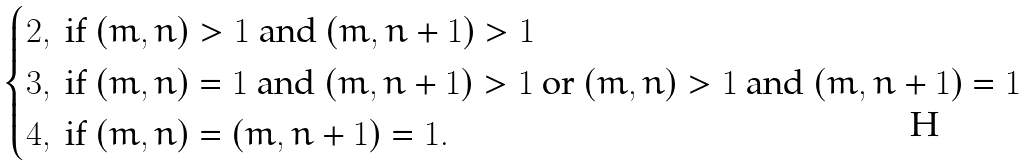Convert formula to latex. <formula><loc_0><loc_0><loc_500><loc_500>\begin{cases} 2 , \ \text {if $(m,n)>1$ and $(m,n+1)>1$} \\ 3 , \ \text {if $(m,n)=1$ and $(m,n+1)>1$ or $(m,n)>1$ and      $(m,n+1)=1$} \\ 4 , \ \text {if $(m,n)=(m,n+1)=1$} . \end{cases}</formula> 